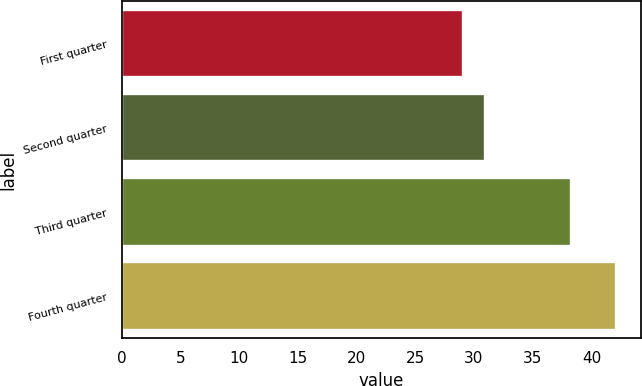Convert chart to OTSL. <chart><loc_0><loc_0><loc_500><loc_500><bar_chart><fcel>First quarter<fcel>Second quarter<fcel>Third quarter<fcel>Fourth quarter<nl><fcel>29.1<fcel>30.96<fcel>38.3<fcel>42.11<nl></chart> 